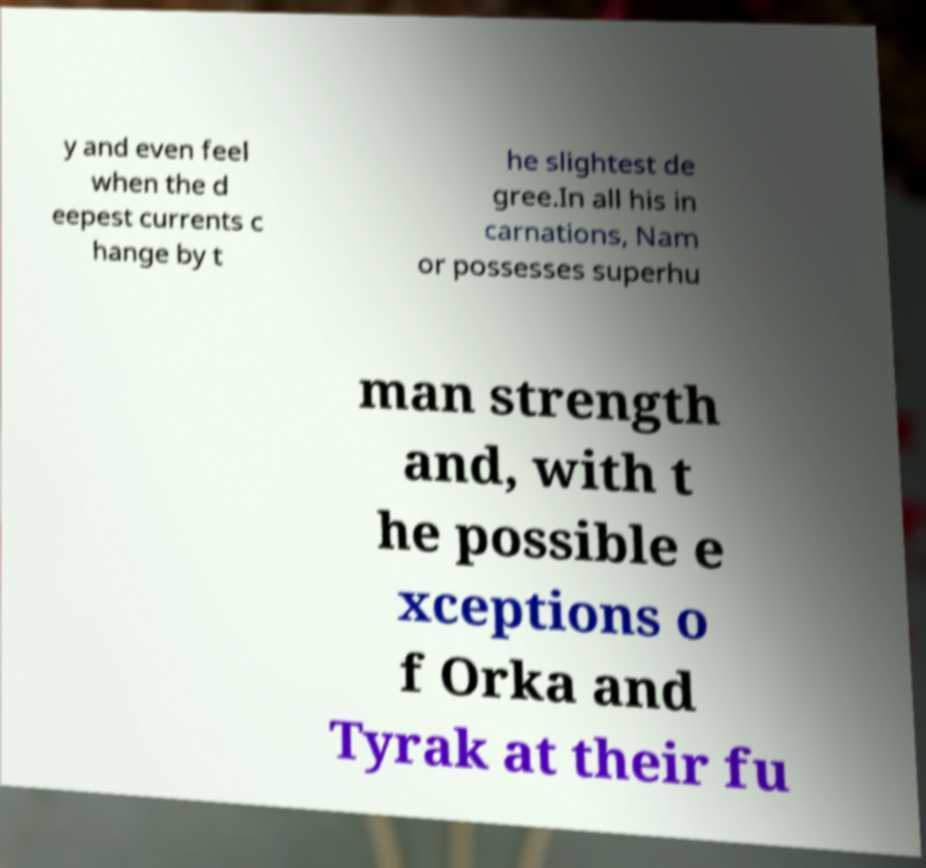Please read and relay the text visible in this image. What does it say? y and even feel when the d eepest currents c hange by t he slightest de gree.In all his in carnations, Nam or possesses superhu man strength and, with t he possible e xceptions o f Orka and Tyrak at their fu 